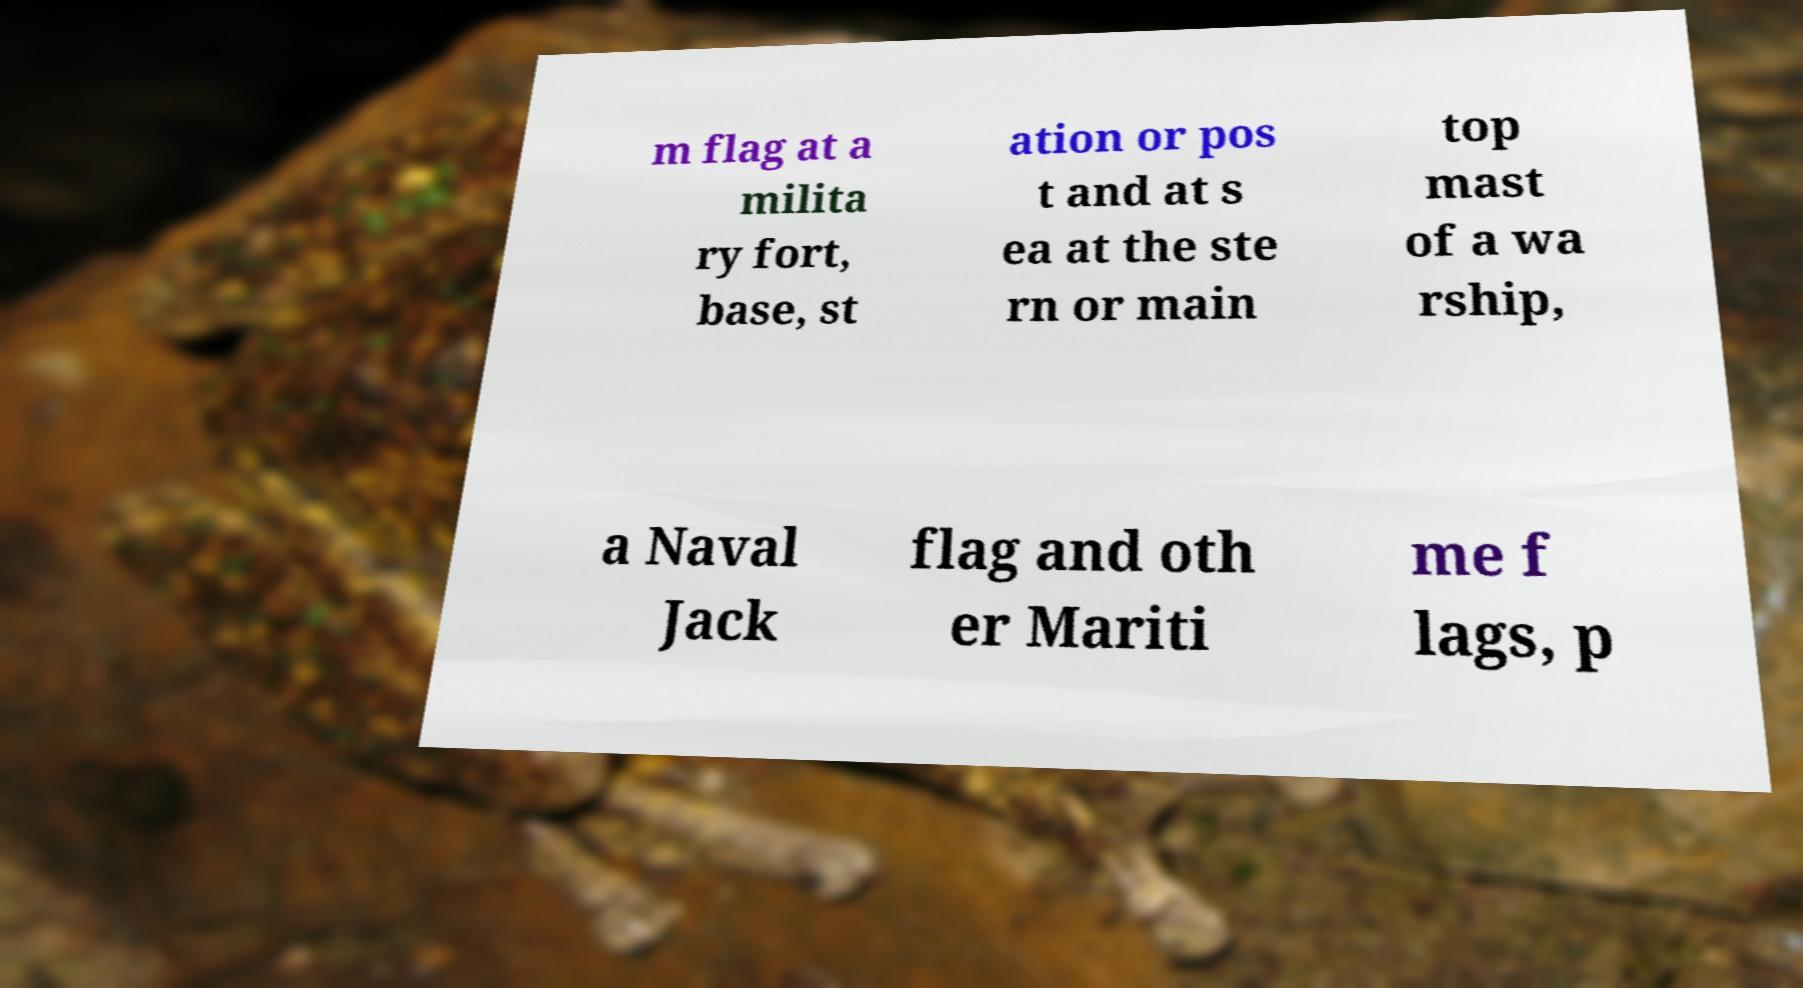I need the written content from this picture converted into text. Can you do that? m flag at a milita ry fort, base, st ation or pos t and at s ea at the ste rn or main top mast of a wa rship, a Naval Jack flag and oth er Mariti me f lags, p 